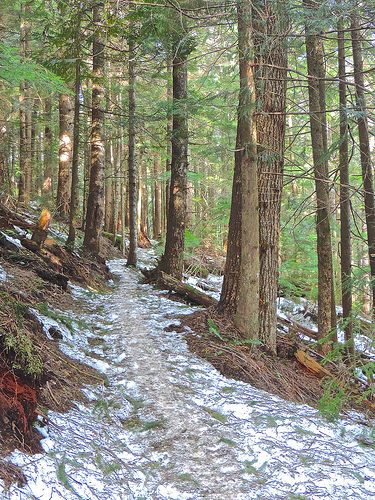<image>
Is there a path behind the tree? No. The path is not behind the tree. From this viewpoint, the path appears to be positioned elsewhere in the scene. 